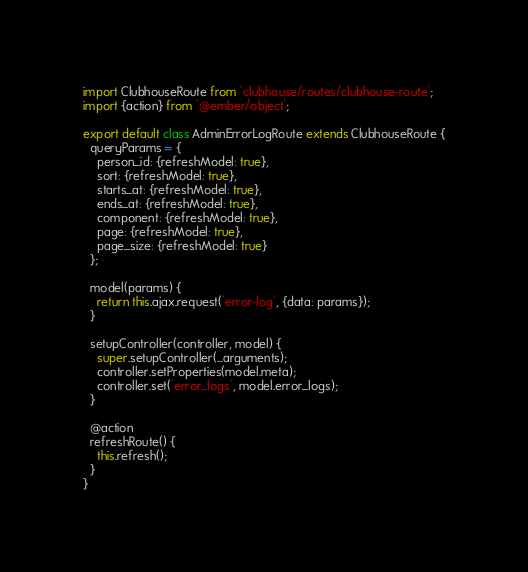<code> <loc_0><loc_0><loc_500><loc_500><_JavaScript_>import ClubhouseRoute from 'clubhouse/routes/clubhouse-route';
import {action} from '@ember/object';

export default class AdminErrorLogRoute extends ClubhouseRoute {
  queryParams = {
    person_id: {refreshModel: true},
    sort: {refreshModel: true},
    starts_at: {refreshModel: true},
    ends_at: {refreshModel: true},
    component: {refreshModel: true},
    page: {refreshModel: true},
    page_size: {refreshModel: true}
  };

  model(params) {
    return this.ajax.request('error-log', {data: params});
  }

  setupController(controller, model) {
    super.setupController(...arguments);
    controller.setProperties(model.meta);
    controller.set('error_logs', model.error_logs);
  }

  @action
  refreshRoute() {
    this.refresh();
  }
}
</code> 